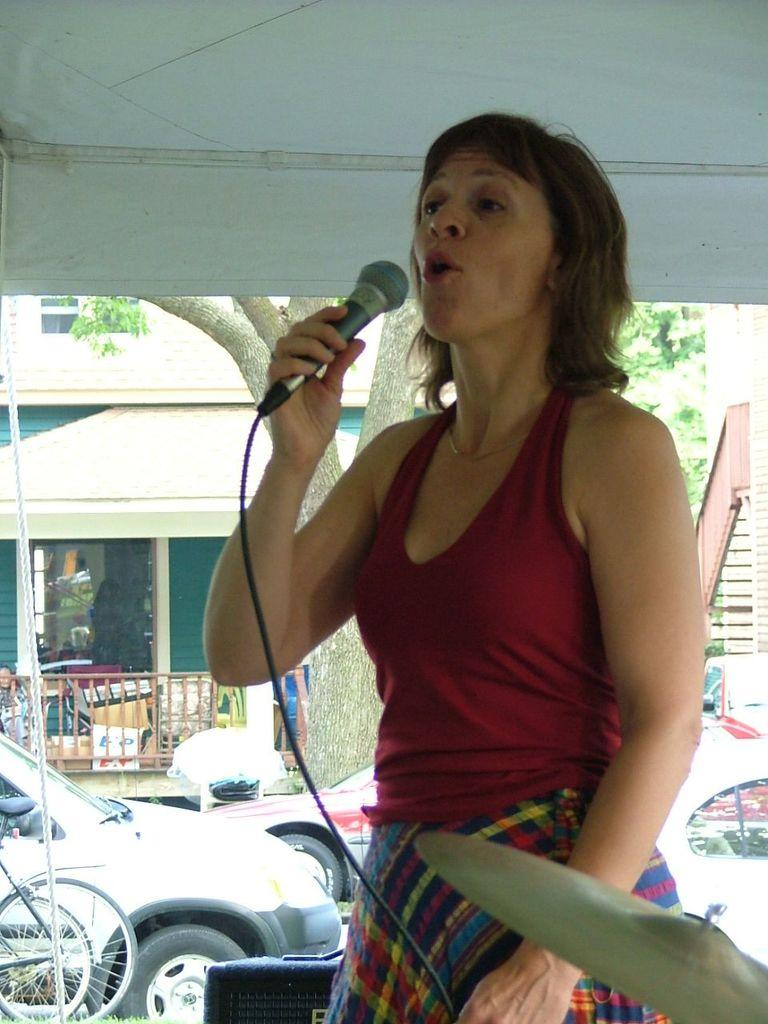What is the woman in the image doing? The woman is singing in the image. What is the woman holding while singing? The woman is holding a microphone. What types of vehicles can be seen in the image? Cars and bicycles can be seen in the image. What can be seen in the background of the image? There is a tree and a house in the background of the image. How many eyes does the sponge have in the image? There is no sponge present in the image, so it is not possible to determine the number of eyes it might have. 